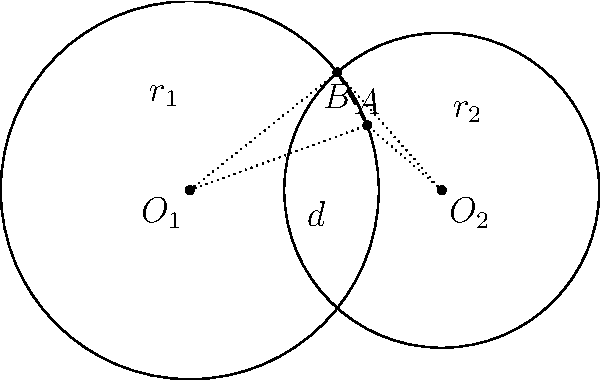In the diagram above, two circles with centers $O_1$ and $O_2$ intersect at points $A$ and $B$. The radius of the circle centered at $O_1$ is $r_1 = 3$ units, the radius of the circle centered at $O_2$ is $r_2 = 2.5$ units, and the distance between the centers is $d = 4$ units. Calculate the length of the common chord $AB$. To find the length of the common chord $AB$, we can use the following steps:

1) First, we need to find the distance from $O_1$ to the common chord. Let's call this distance $h$. We can use the Pythagorean theorem in the right triangle $O_1O_2H$, where $H$ is the midpoint of $AB$:

   $h^2 + (\frac{d}{2})^2 = r_1^2$

2) Rearranging this equation:

   $h^2 = r_1^2 - (\frac{d}{2})^2 = 3^2 - 2^2 = 9 - 4 = 5$

3) Therefore, $h = \sqrt{5}$

4) Now, we can use the Pythagorean theorem again in the right triangle formed by $O_1$, $H$, and $A$:

   $(\frac{AB}{2})^2 + h^2 = r_1^2$

5) Substituting the known values:

   $(\frac{AB}{2})^2 + 5 = 9$

6) Solving for $AB$:

   $(\frac{AB}{2})^2 = 4$
   $\frac{AB}{2} = 2$
   $AB = 4$

Therefore, the length of the common chord $AB$ is 4 units.
Answer: 4 units 